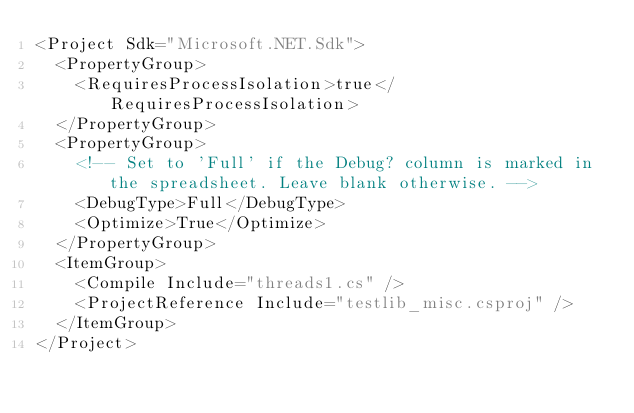<code> <loc_0><loc_0><loc_500><loc_500><_XML_><Project Sdk="Microsoft.NET.Sdk">
  <PropertyGroup>
    <RequiresProcessIsolation>true</RequiresProcessIsolation>
  </PropertyGroup>
  <PropertyGroup>
    <!-- Set to 'Full' if the Debug? column is marked in the spreadsheet. Leave blank otherwise. -->
    <DebugType>Full</DebugType>
    <Optimize>True</Optimize>
  </PropertyGroup>
  <ItemGroup>
    <Compile Include="threads1.cs" />
    <ProjectReference Include="testlib_misc.csproj" />
  </ItemGroup>
</Project>
</code> 